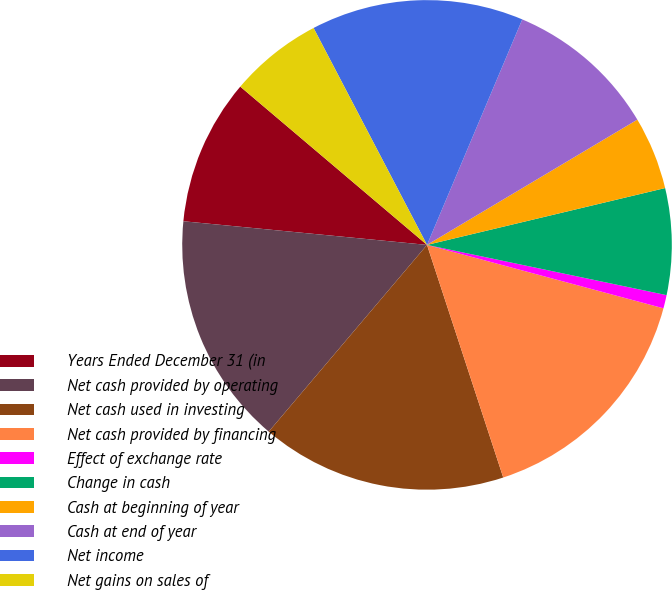<chart> <loc_0><loc_0><loc_500><loc_500><pie_chart><fcel>Years Ended December 31 (in<fcel>Net cash provided by operating<fcel>Net cash used in investing<fcel>Net cash provided by financing<fcel>Effect of exchange rate<fcel>Change in cash<fcel>Cash at beginning of year<fcel>Cash at end of year<fcel>Net income<fcel>Net gains on sales of<nl><fcel>9.65%<fcel>15.35%<fcel>16.23%<fcel>15.79%<fcel>0.88%<fcel>7.02%<fcel>4.82%<fcel>10.09%<fcel>14.03%<fcel>6.14%<nl></chart> 